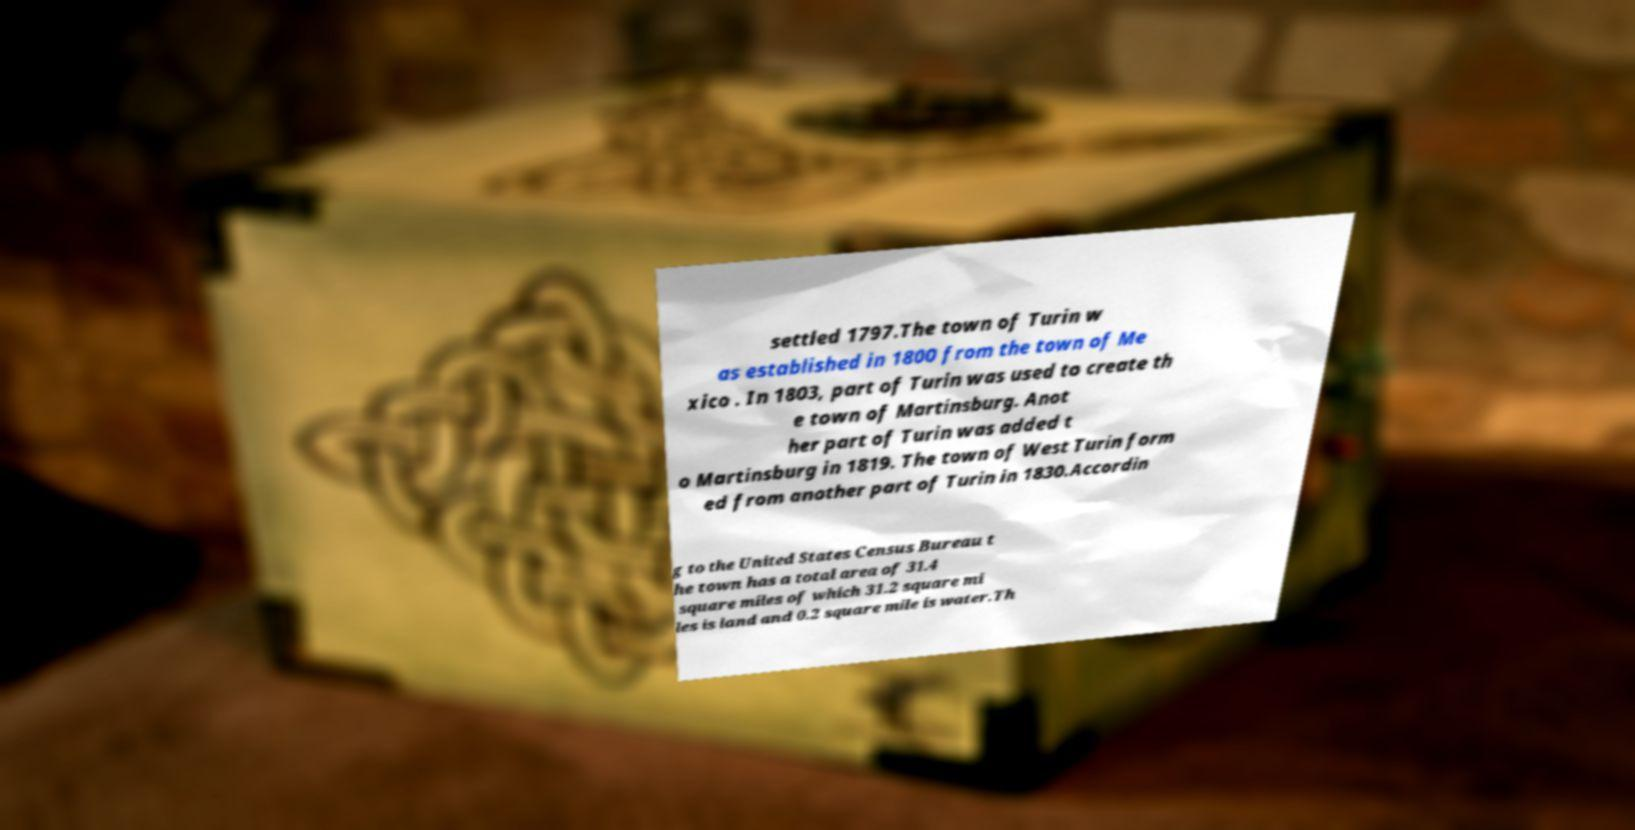Can you accurately transcribe the text from the provided image for me? settled 1797.The town of Turin w as established in 1800 from the town of Me xico . In 1803, part of Turin was used to create th e town of Martinsburg. Anot her part of Turin was added t o Martinsburg in 1819. The town of West Turin form ed from another part of Turin in 1830.Accordin g to the United States Census Bureau t he town has a total area of 31.4 square miles of which 31.2 square mi les is land and 0.2 square mile is water.Th 